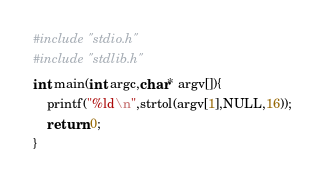<code> <loc_0><loc_0><loc_500><loc_500><_C_>#include "stdio.h"
#include "stdlib.h"
int main(int argc,char* argv[]){
    printf("%ld\n",strtol(argv[1],NULL,16));
    return 0;
}

</code> 